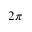<formula> <loc_0><loc_0><loc_500><loc_500>2 \pi</formula> 